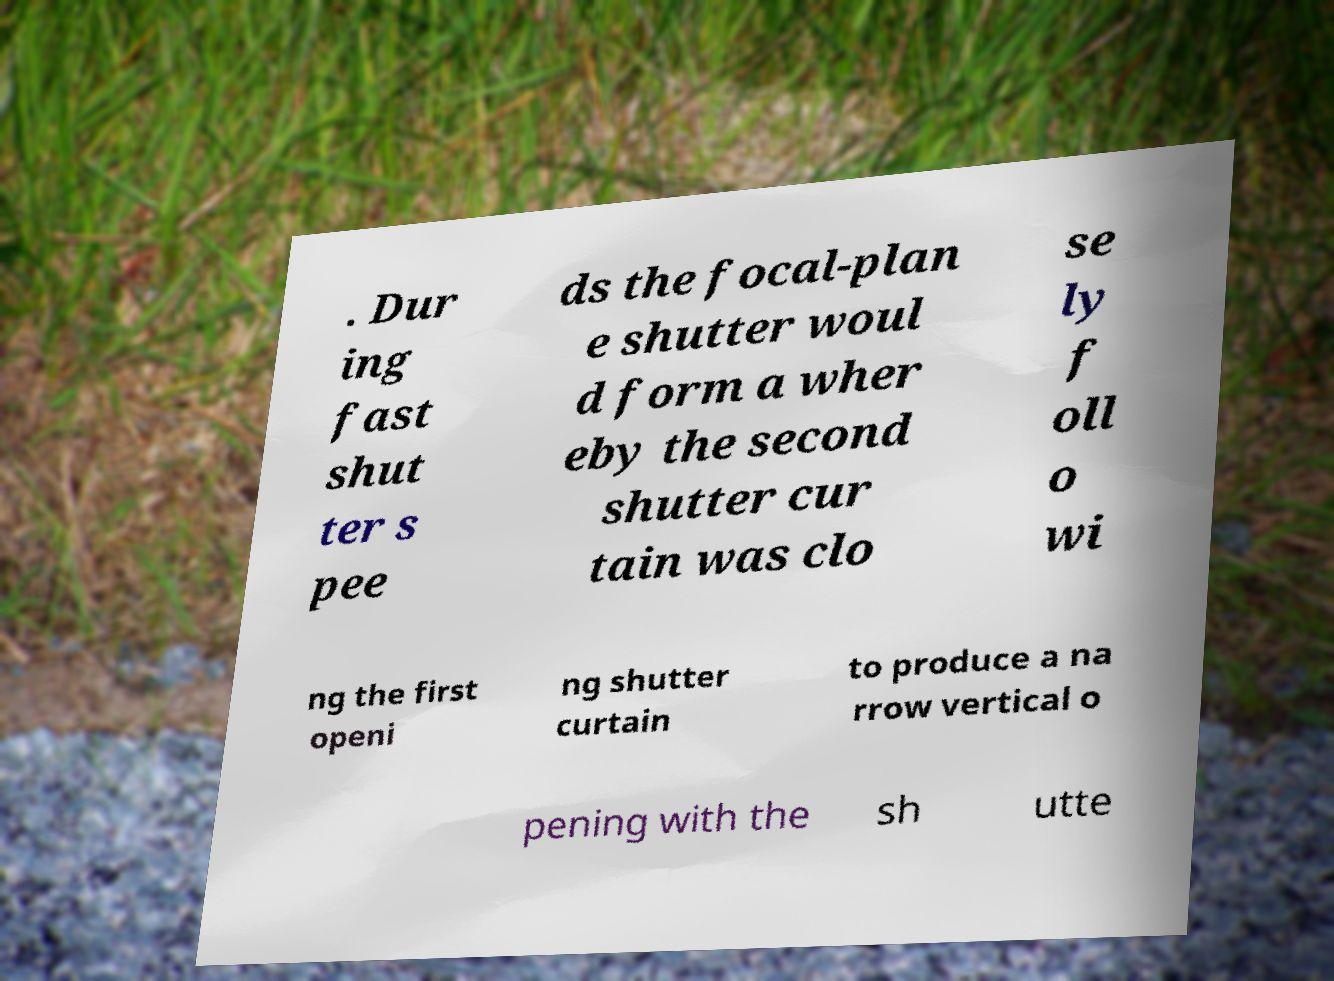What messages or text are displayed in this image? I need them in a readable, typed format. . Dur ing fast shut ter s pee ds the focal-plan e shutter woul d form a wher eby the second shutter cur tain was clo se ly f oll o wi ng the first openi ng shutter curtain to produce a na rrow vertical o pening with the sh utte 